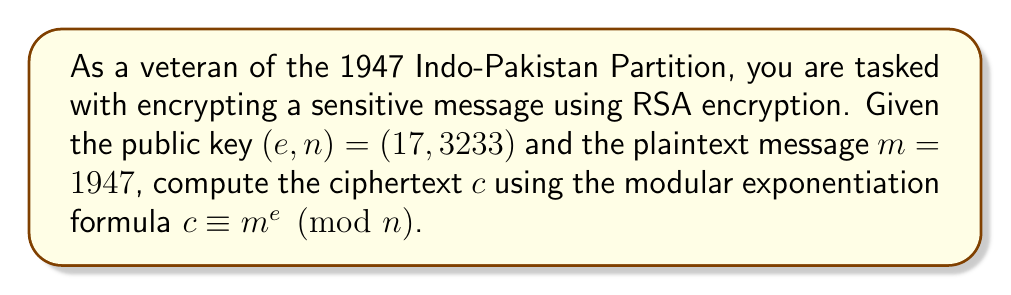Teach me how to tackle this problem. To compute the modular exponentiation for RSA encryption, we need to follow these steps:

1) We are given:
   - Public exponent $e = 17$
   - Modulus $n = 3233$
   - Plaintext message $m = 1947$

2) We need to calculate $c \equiv m^e \pmod{n}$, which is:

   $c \equiv 1947^{17} \pmod{3233}$

3) This is a large exponentiation, so we'll use the square-and-multiply algorithm:

   $1947^{17} = 1947^{(10001)_2}$ (17 in binary)

4) Let's compute step by step:
   
   $1947^1 \equiv 1947 \pmod{3233}$
   
   $1947^2 \equiv 1947^2 \pmod{3233} \equiv 2401 \pmod{3233}$
   
   $1947^4 \equiv 2401^2 \pmod{3233} \equiv 1600 \pmod{3233}$
   
   $1947^8 \equiv 1600^2 \pmod{3233} \equiv 2089 \pmod{3233}$
   
   $1947^{16} \equiv 2089^2 \pmod{3233} \equiv 2537 \pmod{3233}$

5) Now, we combine these results according to the binary representation of 17:

   $1947^{17} \equiv 1947^{16} \cdot 1947^1 \pmod{3233}$
   
   $\equiv 2537 \cdot 1947 \pmod{3233}$
   
   $\equiv 2180 \pmod{3233}$

Therefore, the ciphertext $c$ is 2180.
Answer: $c = 2180$ 